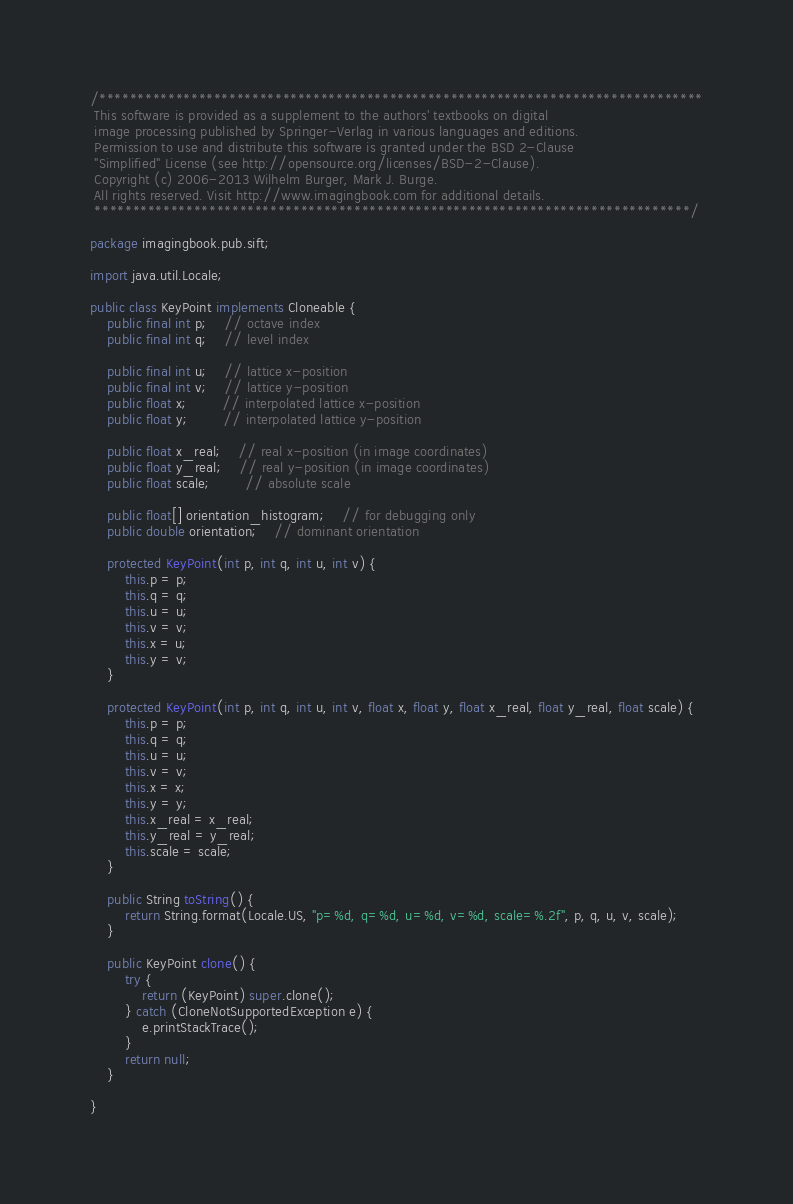<code> <loc_0><loc_0><loc_500><loc_500><_Java_>/*******************************************************************************
 This software is provided as a supplement to the authors' textbooks on digital
 image processing published by Springer-Verlag in various languages and editions.
 Permission to use and distribute this software is granted under the BSD 2-Clause 
 "Simplified" License (see http://opensource.org/licenses/BSD-2-Clause). 
 Copyright (c) 2006-2013 Wilhelm Burger, Mark J. Burge. 
 All rights reserved. Visit http://www.imagingbook.com for additional details.
 ******************************************************************************/

package imagingbook.pub.sift;

import java.util.Locale;

public class KeyPoint implements Cloneable {
	public final int p;	// octave index
	public final int q;	// level index
	
	public final int u;	// lattice x-position 
	public final int v;	// lattice y-position 
	public float x;		// interpolated lattice x-position 
	public float y;		// interpolated lattice y-position 
	
	public float x_real;	// real x-position (in image coordinates)		
	public float y_real;	// real y-position (in image coordinates)		
	public float scale;		// absolute scale
	
	public float[] orientation_histogram;	// for debugging only
	public double orientation;	// dominant orientation
	
	protected KeyPoint(int p, int q, int u, int v) {
		this.p = p;
		this.q = q;
		this.u = u;
		this.v = v;
		this.x = u;
		this.y = v;
	}
	
	protected KeyPoint(int p, int q, int u, int v, float x, float y, float x_real, float y_real, float scale) {
		this.p = p;
		this.q = q;
		this.u = u;
		this.v = v;
		this.x = x;
		this.y = y;
		this.x_real = x_real;
		this.y_real = y_real;
		this.scale = scale;
	}
	
	public String toString() {
		return String.format(Locale.US, "p=%d, q=%d, u=%d, v=%d, scale=%.2f", p, q, u, v, scale);
	}
	
	public KeyPoint clone() {
		try {
			return (KeyPoint) super.clone();
		} catch (CloneNotSupportedException e) {
			e.printStackTrace();
		}
		return null;
	}

}
</code> 